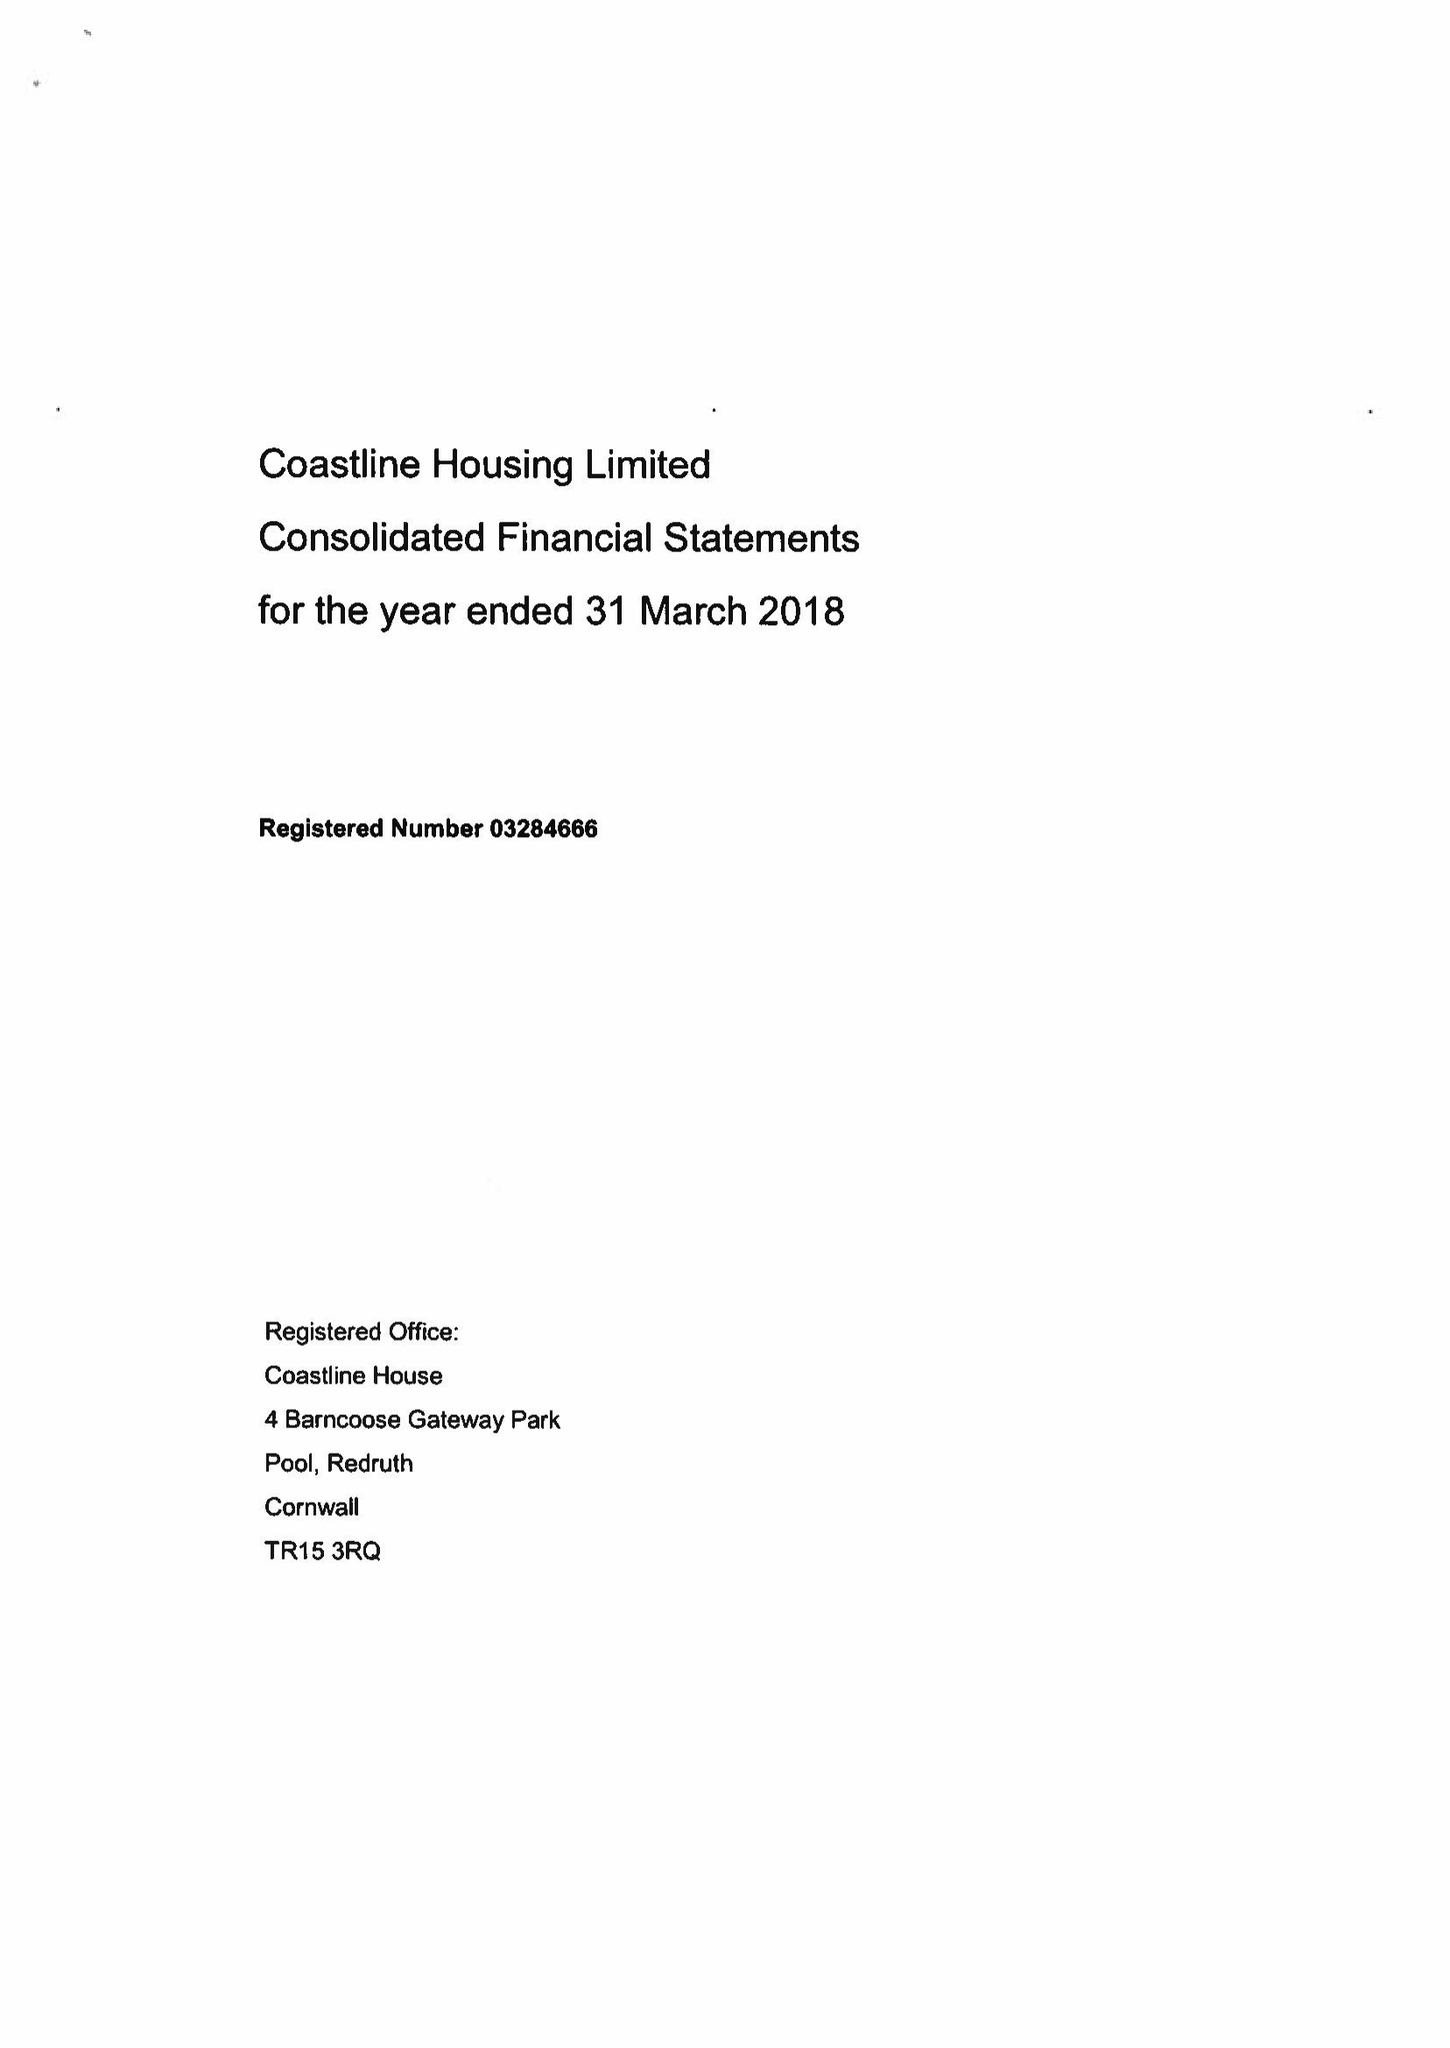What is the value for the income_annually_in_british_pounds?
Answer the question using a single word or phrase. 32889000.00 